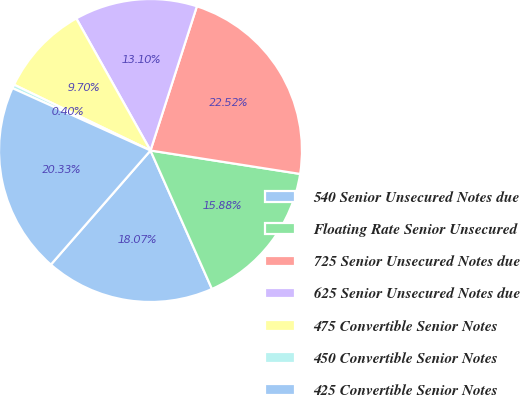Convert chart to OTSL. <chart><loc_0><loc_0><loc_500><loc_500><pie_chart><fcel>540 Senior Unsecured Notes due<fcel>Floating Rate Senior Unsecured<fcel>725 Senior Unsecured Notes due<fcel>625 Senior Unsecured Notes due<fcel>475 Convertible Senior Notes<fcel>450 Convertible Senior Notes<fcel>425 Convertible Senior Notes<nl><fcel>18.07%<fcel>15.88%<fcel>22.52%<fcel>13.1%<fcel>9.7%<fcel>0.4%<fcel>20.33%<nl></chart> 